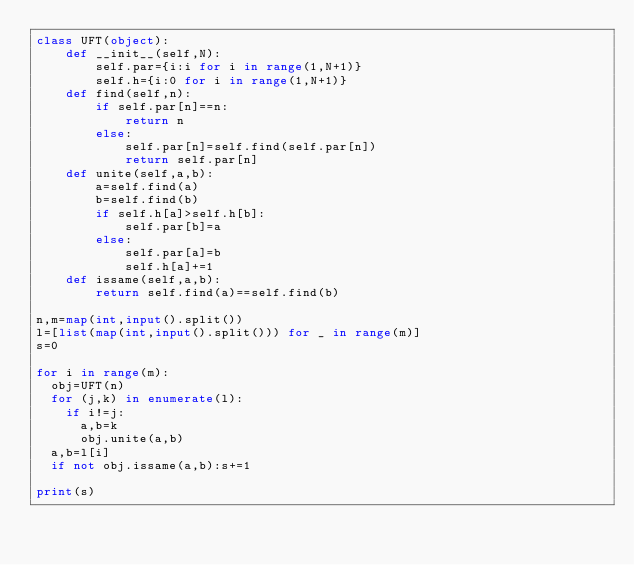Convert code to text. <code><loc_0><loc_0><loc_500><loc_500><_Python_>class UFT(object):
    def __init__(self,N):
        self.par={i:i for i in range(1,N+1)}
        self.h={i:0 for i in range(1,N+1)}
    def find(self,n):
        if self.par[n]==n:
            return n
        else:
            self.par[n]=self.find(self.par[n])
            return self.par[n]
    def unite(self,a,b):
        a=self.find(a)
        b=self.find(b)
        if self.h[a]>self.h[b]:
            self.par[b]=a
        else:
            self.par[a]=b
            self.h[a]+=1
    def issame(self,a,b):
        return self.find(a)==self.find(b)

n,m=map(int,input().split())
l=[list(map(int,input().split())) for _ in range(m)]
s=0

for i in range(m):
  obj=UFT(n)
  for (j,k) in enumerate(l):
    if i!=j:
      a,b=k
      obj.unite(a,b)
  a,b=l[i]
  if not obj.issame(a,b):s+=1

print(s)</code> 